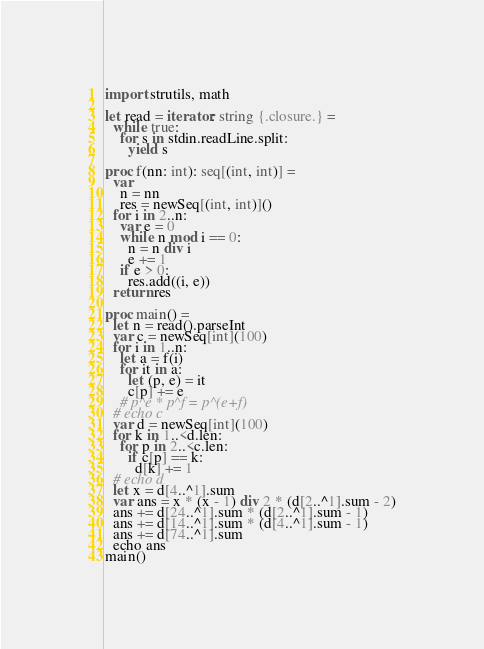<code> <loc_0><loc_0><loc_500><loc_500><_Nim_>
import strutils, math

let read = iterator: string {.closure.} =
  while true:
    for s in stdin.readLine.split:
      yield s

proc f(nn: int): seq[(int, int)] =
  var
    n = nn
    res = newSeq[(int, int)]()
  for i in 2..n:
    var e = 0
    while n mod i == 0:
      n = n div i
      e += 1
    if e > 0:
      res.add((i, e))
  return res

proc main() =
  let n = read().parseInt
  var c = newSeq[int](100)
  for i in 1..n:
    let a = f(i)
    for it in a:
      let (p, e) = it
      c[p] += e
    # p^e * p^f = p^(e+f)
  # echo c
  var d = newSeq[int](100)
  for k in 1..<d.len:
    for p in 2..<c.len:
      if c[p] == k:
        d[k] += 1
  # echo d
  let x = d[4..^1].sum
  var ans = x * (x - 1) div 2 * (d[2..^1].sum - 2)
  ans += d[24..^1].sum * (d[2..^1].sum - 1)
  ans += d[14..^1].sum * (d[4..^1].sum - 1)
  ans += d[74..^1].sum
  echo ans
main()</code> 